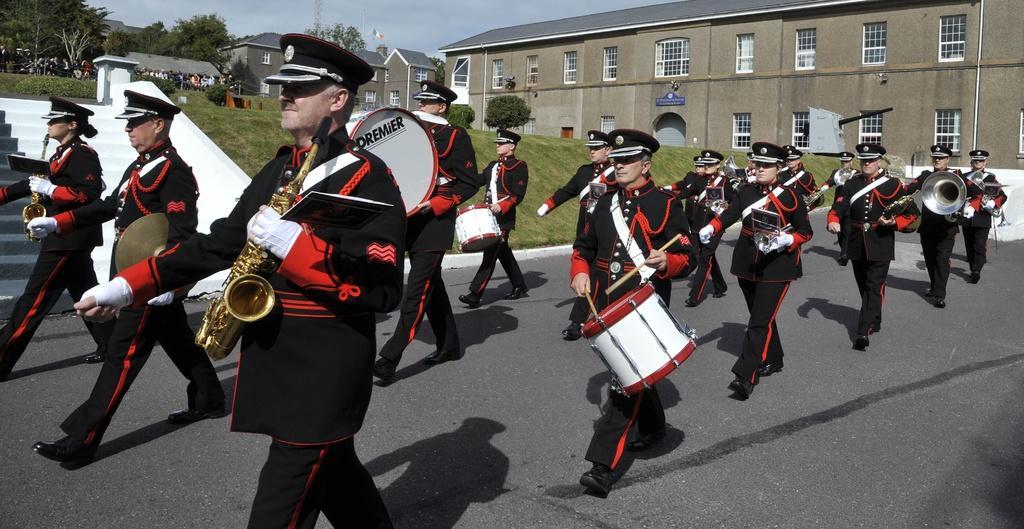Could you give a brief overview of what you see in this image? In the image I can see few people holding different musical instruments and wearing black and red color dress. Back I can see few buildings,glass windows,trees,stairs and flag. The sky is in blue color. 